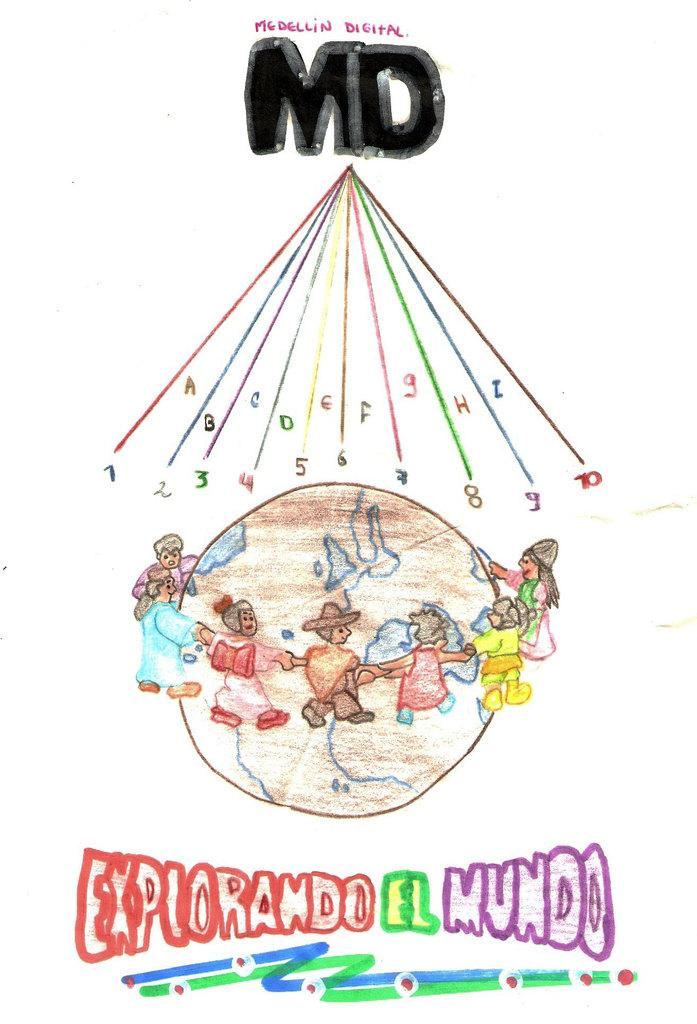<image>
Summarize the visual content of the image. A hand drawn poster with children holding hands around a glob above the words explorando el mundo. 